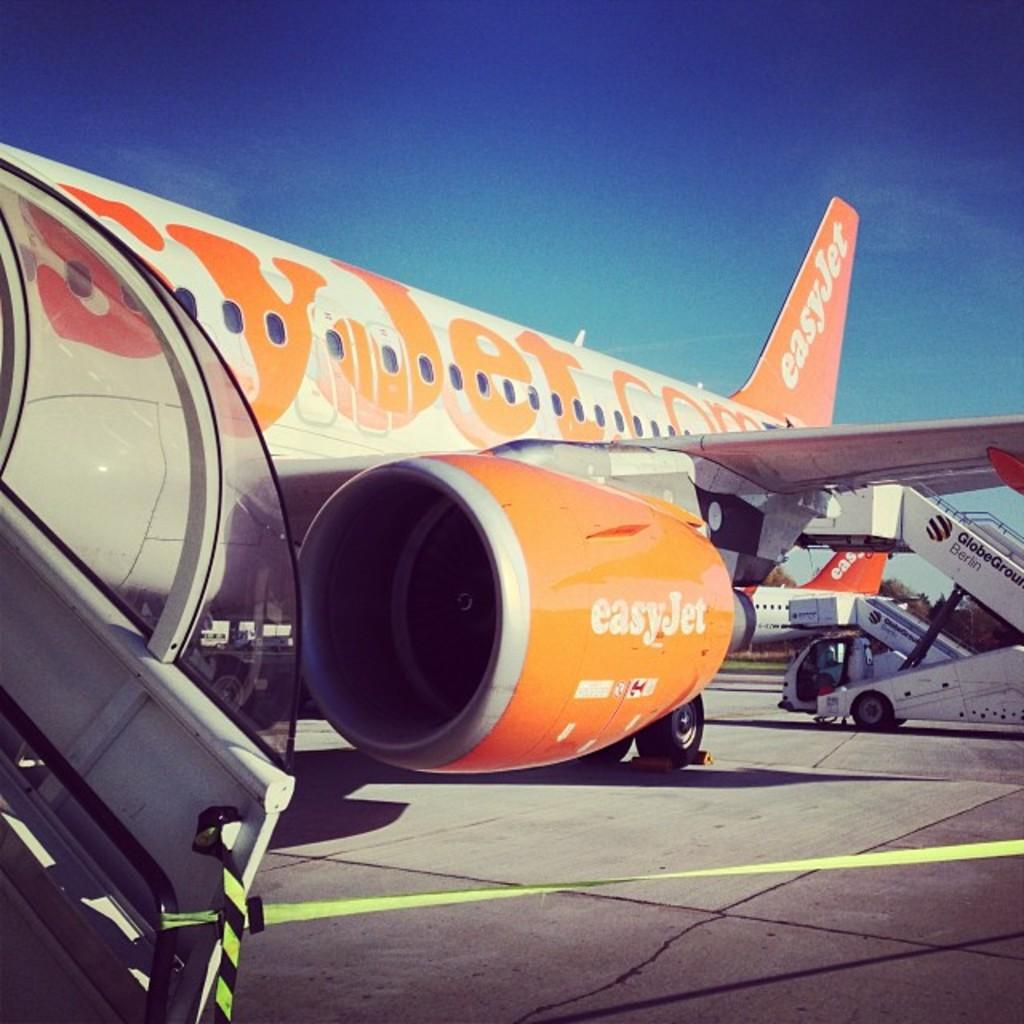Provide a one-sentence caption for the provided image. An Easy Jet plane stands idle on an airport runway. 